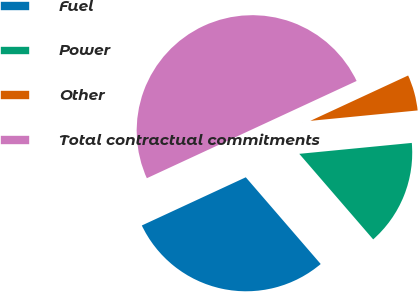Convert chart. <chart><loc_0><loc_0><loc_500><loc_500><pie_chart><fcel>Fuel<fcel>Power<fcel>Other<fcel>Total contractual commitments<nl><fcel>29.43%<fcel>15.2%<fcel>5.37%<fcel>50.0%<nl></chart> 